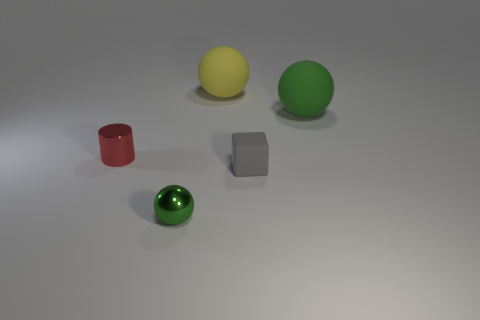Add 4 purple metallic things. How many objects exist? 9 Subtract all blocks. How many objects are left? 4 Add 4 small metal things. How many small metal things are left? 6 Add 3 tiny purple balls. How many tiny purple balls exist? 3 Subtract 0 green cubes. How many objects are left? 5 Subtract all large red metallic cylinders. Subtract all red cylinders. How many objects are left? 4 